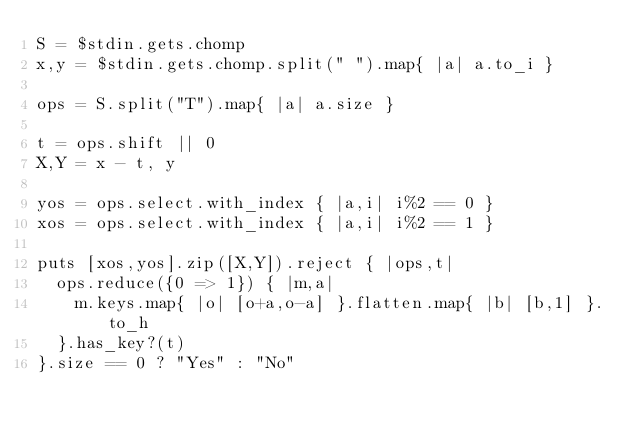Convert code to text. <code><loc_0><loc_0><loc_500><loc_500><_Ruby_>S = $stdin.gets.chomp
x,y = $stdin.gets.chomp.split(" ").map{ |a| a.to_i }

ops = S.split("T").map{ |a| a.size }

t = ops.shift || 0
X,Y = x - t, y

yos = ops.select.with_index { |a,i| i%2 == 0 }
xos = ops.select.with_index { |a,i| i%2 == 1 }

puts [xos,yos].zip([X,Y]).reject { |ops,t|
  ops.reduce({0 => 1}) { |m,a|
    m.keys.map{ |o| [o+a,o-a] }.flatten.map{ |b| [b,1] }.to_h
  }.has_key?(t)
}.size == 0 ? "Yes" : "No"
</code> 